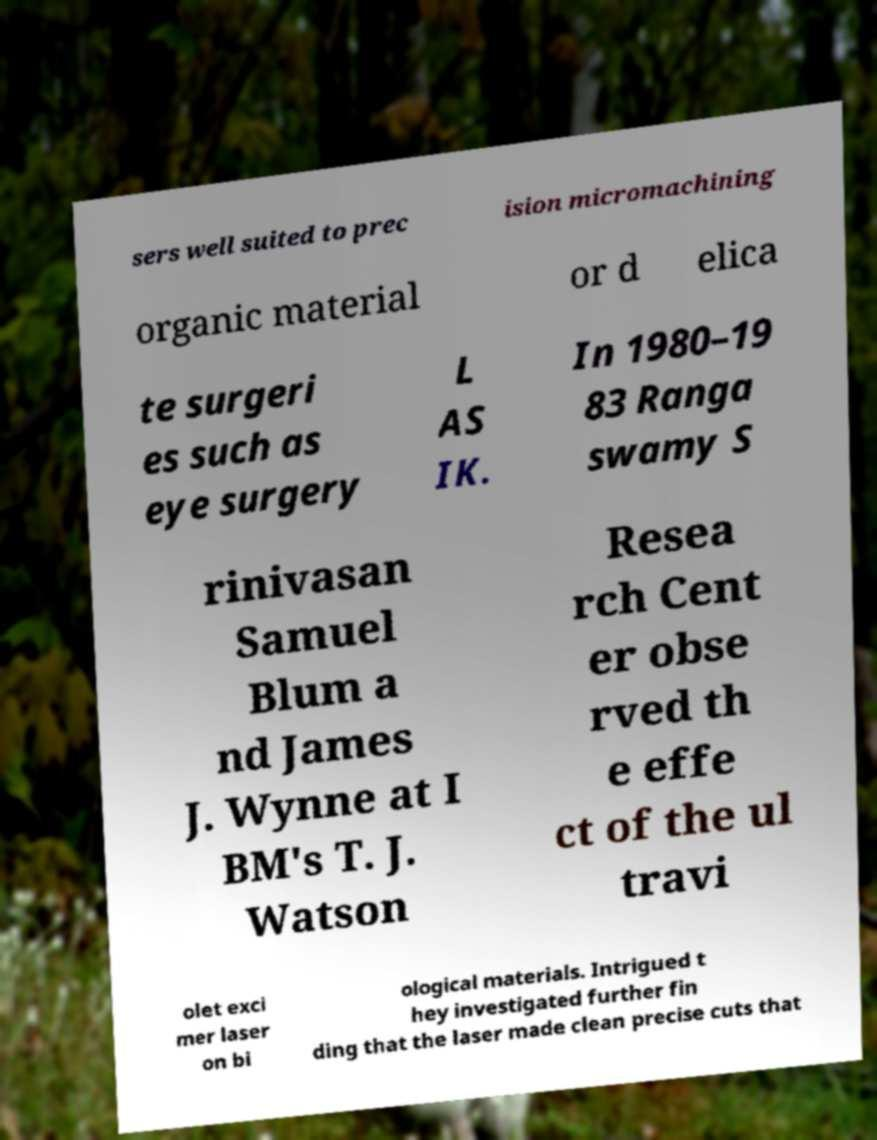For documentation purposes, I need the text within this image transcribed. Could you provide that? sers well suited to prec ision micromachining organic material or d elica te surgeri es such as eye surgery L AS IK. In 1980–19 83 Ranga swamy S rinivasan Samuel Blum a nd James J. Wynne at I BM's T. J. Watson Resea rch Cent er obse rved th e effe ct of the ul travi olet exci mer laser on bi ological materials. Intrigued t hey investigated further fin ding that the laser made clean precise cuts that 